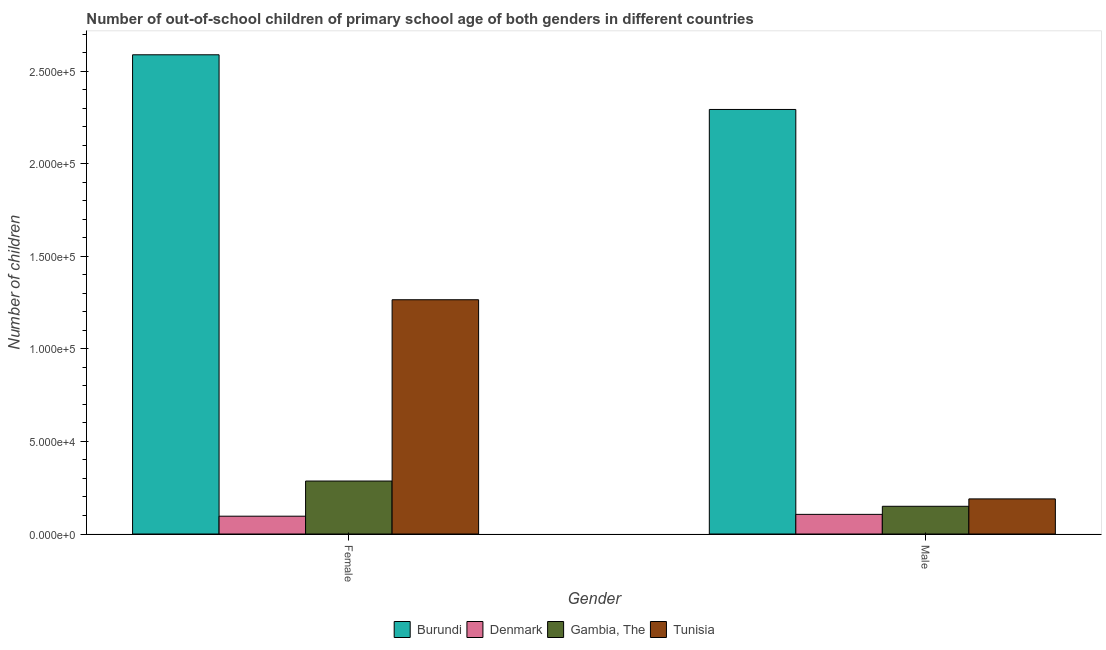How many groups of bars are there?
Your answer should be compact. 2. How many bars are there on the 1st tick from the left?
Offer a terse response. 4. What is the number of female out-of-school students in Tunisia?
Give a very brief answer. 1.27e+05. Across all countries, what is the maximum number of male out-of-school students?
Provide a short and direct response. 2.29e+05. Across all countries, what is the minimum number of male out-of-school students?
Provide a short and direct response. 1.06e+04. In which country was the number of male out-of-school students maximum?
Your answer should be very brief. Burundi. What is the total number of female out-of-school students in the graph?
Keep it short and to the point. 4.24e+05. What is the difference between the number of female out-of-school students in Tunisia and that in Gambia, The?
Keep it short and to the point. 9.79e+04. What is the difference between the number of female out-of-school students in Gambia, The and the number of male out-of-school students in Burundi?
Your answer should be compact. -2.01e+05. What is the average number of female out-of-school students per country?
Give a very brief answer. 1.06e+05. What is the difference between the number of male out-of-school students and number of female out-of-school students in Tunisia?
Keep it short and to the point. -1.08e+05. In how many countries, is the number of male out-of-school students greater than 210000 ?
Offer a terse response. 1. What is the ratio of the number of female out-of-school students in Denmark to that in Gambia, The?
Provide a short and direct response. 0.34. In how many countries, is the number of male out-of-school students greater than the average number of male out-of-school students taken over all countries?
Your response must be concise. 1. What does the 4th bar from the left in Female represents?
Provide a succinct answer. Tunisia. How many bars are there?
Offer a very short reply. 8. What is the difference between two consecutive major ticks on the Y-axis?
Keep it short and to the point. 5.00e+04. Does the graph contain grids?
Provide a short and direct response. No. Where does the legend appear in the graph?
Provide a short and direct response. Bottom center. How are the legend labels stacked?
Keep it short and to the point. Horizontal. What is the title of the graph?
Provide a short and direct response. Number of out-of-school children of primary school age of both genders in different countries. Does "Bermuda" appear as one of the legend labels in the graph?
Your answer should be very brief. No. What is the label or title of the Y-axis?
Your response must be concise. Number of children. What is the Number of children in Burundi in Female?
Provide a short and direct response. 2.59e+05. What is the Number of children in Denmark in Female?
Provide a succinct answer. 9621. What is the Number of children in Gambia, The in Female?
Your answer should be very brief. 2.86e+04. What is the Number of children of Tunisia in Female?
Your answer should be very brief. 1.27e+05. What is the Number of children in Burundi in Male?
Your answer should be compact. 2.29e+05. What is the Number of children of Denmark in Male?
Offer a terse response. 1.06e+04. What is the Number of children of Gambia, The in Male?
Ensure brevity in your answer.  1.50e+04. What is the Number of children in Tunisia in Male?
Your answer should be very brief. 1.90e+04. Across all Gender, what is the maximum Number of children in Burundi?
Provide a short and direct response. 2.59e+05. Across all Gender, what is the maximum Number of children in Denmark?
Your response must be concise. 1.06e+04. Across all Gender, what is the maximum Number of children in Gambia, The?
Ensure brevity in your answer.  2.86e+04. Across all Gender, what is the maximum Number of children of Tunisia?
Your answer should be compact. 1.27e+05. Across all Gender, what is the minimum Number of children in Burundi?
Make the answer very short. 2.29e+05. Across all Gender, what is the minimum Number of children in Denmark?
Offer a terse response. 9621. Across all Gender, what is the minimum Number of children in Gambia, The?
Your answer should be compact. 1.50e+04. Across all Gender, what is the minimum Number of children of Tunisia?
Provide a succinct answer. 1.90e+04. What is the total Number of children in Burundi in the graph?
Keep it short and to the point. 4.88e+05. What is the total Number of children of Denmark in the graph?
Offer a terse response. 2.02e+04. What is the total Number of children in Gambia, The in the graph?
Your answer should be compact. 4.36e+04. What is the total Number of children of Tunisia in the graph?
Offer a very short reply. 1.45e+05. What is the difference between the Number of children of Burundi in Female and that in Male?
Offer a terse response. 2.95e+04. What is the difference between the Number of children in Denmark in Female and that in Male?
Your answer should be very brief. -987. What is the difference between the Number of children of Gambia, The in Female and that in Male?
Make the answer very short. 1.36e+04. What is the difference between the Number of children in Tunisia in Female and that in Male?
Ensure brevity in your answer.  1.08e+05. What is the difference between the Number of children in Burundi in Female and the Number of children in Denmark in Male?
Make the answer very short. 2.48e+05. What is the difference between the Number of children of Burundi in Female and the Number of children of Gambia, The in Male?
Your answer should be compact. 2.44e+05. What is the difference between the Number of children in Burundi in Female and the Number of children in Tunisia in Male?
Keep it short and to the point. 2.40e+05. What is the difference between the Number of children of Denmark in Female and the Number of children of Gambia, The in Male?
Make the answer very short. -5349. What is the difference between the Number of children in Denmark in Female and the Number of children in Tunisia in Male?
Provide a succinct answer. -9338. What is the difference between the Number of children in Gambia, The in Female and the Number of children in Tunisia in Male?
Provide a succinct answer. 9643. What is the average Number of children of Burundi per Gender?
Your answer should be compact. 2.44e+05. What is the average Number of children of Denmark per Gender?
Your answer should be compact. 1.01e+04. What is the average Number of children in Gambia, The per Gender?
Offer a terse response. 2.18e+04. What is the average Number of children of Tunisia per Gender?
Your answer should be compact. 7.27e+04. What is the difference between the Number of children of Burundi and Number of children of Denmark in Female?
Provide a succinct answer. 2.49e+05. What is the difference between the Number of children of Burundi and Number of children of Gambia, The in Female?
Ensure brevity in your answer.  2.30e+05. What is the difference between the Number of children in Burundi and Number of children in Tunisia in Female?
Offer a terse response. 1.32e+05. What is the difference between the Number of children of Denmark and Number of children of Gambia, The in Female?
Provide a succinct answer. -1.90e+04. What is the difference between the Number of children in Denmark and Number of children in Tunisia in Female?
Provide a succinct answer. -1.17e+05. What is the difference between the Number of children of Gambia, The and Number of children of Tunisia in Female?
Give a very brief answer. -9.79e+04. What is the difference between the Number of children of Burundi and Number of children of Denmark in Male?
Your answer should be very brief. 2.19e+05. What is the difference between the Number of children of Burundi and Number of children of Gambia, The in Male?
Your response must be concise. 2.14e+05. What is the difference between the Number of children in Burundi and Number of children in Tunisia in Male?
Offer a terse response. 2.10e+05. What is the difference between the Number of children in Denmark and Number of children in Gambia, The in Male?
Your answer should be very brief. -4362. What is the difference between the Number of children of Denmark and Number of children of Tunisia in Male?
Offer a terse response. -8351. What is the difference between the Number of children of Gambia, The and Number of children of Tunisia in Male?
Offer a terse response. -3989. What is the ratio of the Number of children of Burundi in Female to that in Male?
Provide a succinct answer. 1.13. What is the ratio of the Number of children in Denmark in Female to that in Male?
Your answer should be very brief. 0.91. What is the ratio of the Number of children of Gambia, The in Female to that in Male?
Make the answer very short. 1.91. What is the ratio of the Number of children in Tunisia in Female to that in Male?
Make the answer very short. 6.67. What is the difference between the highest and the second highest Number of children of Burundi?
Your response must be concise. 2.95e+04. What is the difference between the highest and the second highest Number of children of Denmark?
Make the answer very short. 987. What is the difference between the highest and the second highest Number of children of Gambia, The?
Provide a short and direct response. 1.36e+04. What is the difference between the highest and the second highest Number of children of Tunisia?
Provide a succinct answer. 1.08e+05. What is the difference between the highest and the lowest Number of children in Burundi?
Keep it short and to the point. 2.95e+04. What is the difference between the highest and the lowest Number of children of Denmark?
Give a very brief answer. 987. What is the difference between the highest and the lowest Number of children in Gambia, The?
Provide a short and direct response. 1.36e+04. What is the difference between the highest and the lowest Number of children in Tunisia?
Your answer should be very brief. 1.08e+05. 